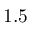<formula> <loc_0><loc_0><loc_500><loc_500>1 . 5</formula> 